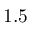<formula> <loc_0><loc_0><loc_500><loc_500>1 . 5</formula> 